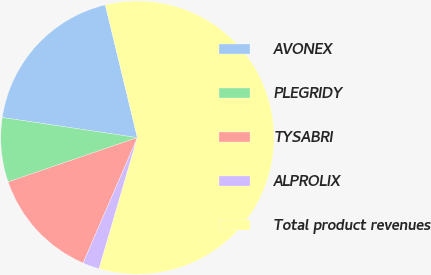Convert chart. <chart><loc_0><loc_0><loc_500><loc_500><pie_chart><fcel>AVONEX<fcel>PLEGRIDY<fcel>TYSABRI<fcel>ALPROLIX<fcel>Total product revenues<nl><fcel>18.87%<fcel>7.61%<fcel>13.24%<fcel>1.98%<fcel>58.29%<nl></chart> 